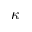<formula> <loc_0><loc_0><loc_500><loc_500>\kappa</formula> 